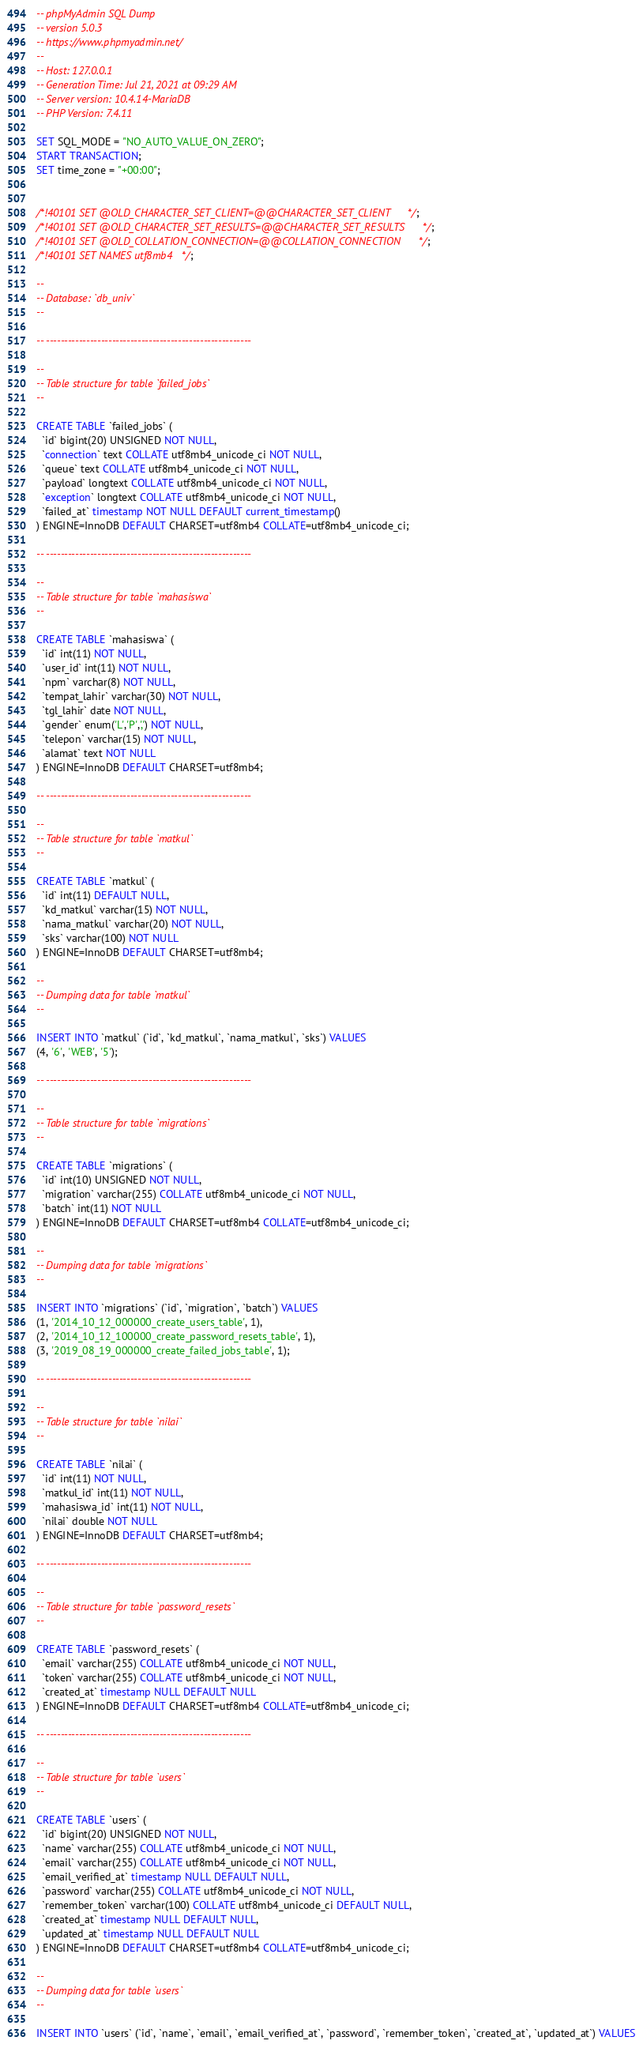Convert code to text. <code><loc_0><loc_0><loc_500><loc_500><_SQL_>-- phpMyAdmin SQL Dump
-- version 5.0.3
-- https://www.phpmyadmin.net/
--
-- Host: 127.0.0.1
-- Generation Time: Jul 21, 2021 at 09:29 AM
-- Server version: 10.4.14-MariaDB
-- PHP Version: 7.4.11

SET SQL_MODE = "NO_AUTO_VALUE_ON_ZERO";
START TRANSACTION;
SET time_zone = "+00:00";


/*!40101 SET @OLD_CHARACTER_SET_CLIENT=@@CHARACTER_SET_CLIENT */;
/*!40101 SET @OLD_CHARACTER_SET_RESULTS=@@CHARACTER_SET_RESULTS */;
/*!40101 SET @OLD_COLLATION_CONNECTION=@@COLLATION_CONNECTION */;
/*!40101 SET NAMES utf8mb4 */;

--
-- Database: `db_univ`
--

-- --------------------------------------------------------

--
-- Table structure for table `failed_jobs`
--

CREATE TABLE `failed_jobs` (
  `id` bigint(20) UNSIGNED NOT NULL,
  `connection` text COLLATE utf8mb4_unicode_ci NOT NULL,
  `queue` text COLLATE utf8mb4_unicode_ci NOT NULL,
  `payload` longtext COLLATE utf8mb4_unicode_ci NOT NULL,
  `exception` longtext COLLATE utf8mb4_unicode_ci NOT NULL,
  `failed_at` timestamp NOT NULL DEFAULT current_timestamp()
) ENGINE=InnoDB DEFAULT CHARSET=utf8mb4 COLLATE=utf8mb4_unicode_ci;

-- --------------------------------------------------------

--
-- Table structure for table `mahasiswa`
--

CREATE TABLE `mahasiswa` (
  `id` int(11) NOT NULL,
  `user_id` int(11) NOT NULL,
  `npm` varchar(8) NOT NULL,
  `tempat_lahir` varchar(30) NOT NULL,
  `tgl_lahir` date NOT NULL,
  `gender` enum('L','P',',') NOT NULL,
  `telepon` varchar(15) NOT NULL,
  `alamat` text NOT NULL
) ENGINE=InnoDB DEFAULT CHARSET=utf8mb4;

-- --------------------------------------------------------

--
-- Table structure for table `matkul`
--

CREATE TABLE `matkul` (
  `id` int(11) DEFAULT NULL,
  `kd_matkul` varchar(15) NOT NULL,
  `nama_matkul` varchar(20) NOT NULL,
  `sks` varchar(100) NOT NULL
) ENGINE=InnoDB DEFAULT CHARSET=utf8mb4;

--
-- Dumping data for table `matkul`
--

INSERT INTO `matkul` (`id`, `kd_matkul`, `nama_matkul`, `sks`) VALUES
(4, '6', 'WEB', '5');

-- --------------------------------------------------------

--
-- Table structure for table `migrations`
--

CREATE TABLE `migrations` (
  `id` int(10) UNSIGNED NOT NULL,
  `migration` varchar(255) COLLATE utf8mb4_unicode_ci NOT NULL,
  `batch` int(11) NOT NULL
) ENGINE=InnoDB DEFAULT CHARSET=utf8mb4 COLLATE=utf8mb4_unicode_ci;

--
-- Dumping data for table `migrations`
--

INSERT INTO `migrations` (`id`, `migration`, `batch`) VALUES
(1, '2014_10_12_000000_create_users_table', 1),
(2, '2014_10_12_100000_create_password_resets_table', 1),
(3, '2019_08_19_000000_create_failed_jobs_table', 1);

-- --------------------------------------------------------

--
-- Table structure for table `nilai`
--

CREATE TABLE `nilai` (
  `id` int(11) NOT NULL,
  `matkul_id` int(11) NOT NULL,
  `mahasiswa_id` int(11) NOT NULL,
  `nilai` double NOT NULL
) ENGINE=InnoDB DEFAULT CHARSET=utf8mb4;

-- --------------------------------------------------------

--
-- Table structure for table `password_resets`
--

CREATE TABLE `password_resets` (
  `email` varchar(255) COLLATE utf8mb4_unicode_ci NOT NULL,
  `token` varchar(255) COLLATE utf8mb4_unicode_ci NOT NULL,
  `created_at` timestamp NULL DEFAULT NULL
) ENGINE=InnoDB DEFAULT CHARSET=utf8mb4 COLLATE=utf8mb4_unicode_ci;

-- --------------------------------------------------------

--
-- Table structure for table `users`
--

CREATE TABLE `users` (
  `id` bigint(20) UNSIGNED NOT NULL,
  `name` varchar(255) COLLATE utf8mb4_unicode_ci NOT NULL,
  `email` varchar(255) COLLATE utf8mb4_unicode_ci NOT NULL,
  `email_verified_at` timestamp NULL DEFAULT NULL,
  `password` varchar(255) COLLATE utf8mb4_unicode_ci NOT NULL,
  `remember_token` varchar(100) COLLATE utf8mb4_unicode_ci DEFAULT NULL,
  `created_at` timestamp NULL DEFAULT NULL,
  `updated_at` timestamp NULL DEFAULT NULL
) ENGINE=InnoDB DEFAULT CHARSET=utf8mb4 COLLATE=utf8mb4_unicode_ci;

--
-- Dumping data for table `users`
--

INSERT INTO `users` (`id`, `name`, `email`, `email_verified_at`, `password`, `remember_token`, `created_at`, `updated_at`) VALUES</code> 